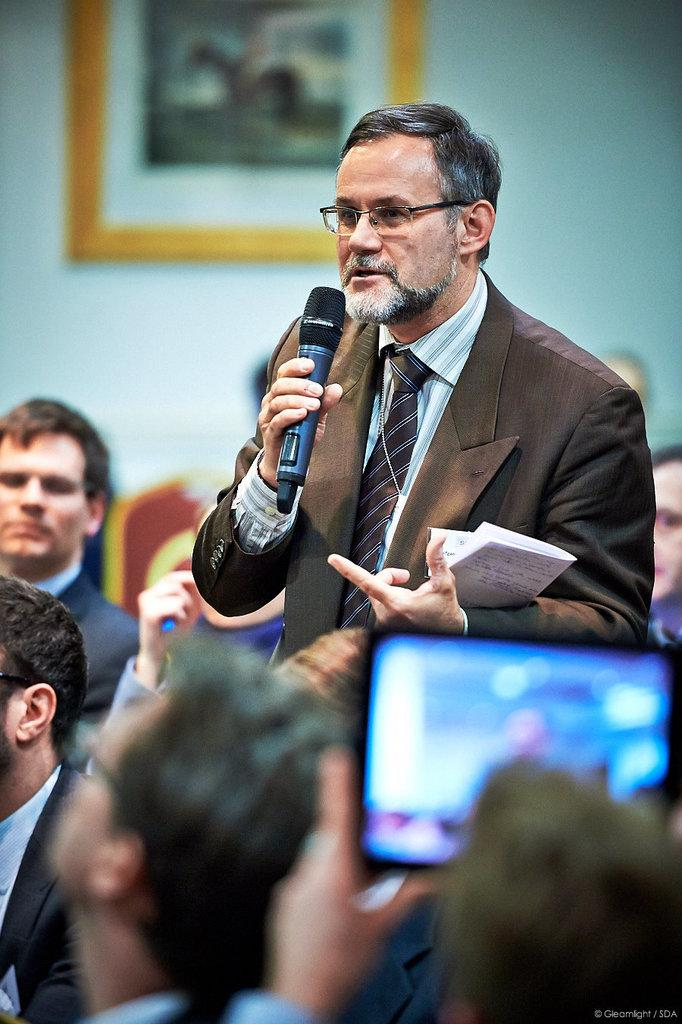What is the man in the image doing? The man is standing and talking into a microphone. What can be seen in the background of the image? There is a group of people sitting in chairs in the background. What electronic device is visible in the image? There is a mobile phone visible in the image. What is attached to the wall in the image? There is a frame attached to a wall in the image. What caption is written on the frame in the image? There is no caption visible on the frame in the image. What type of waste is being disposed of in the image? There is no waste present in the image. 